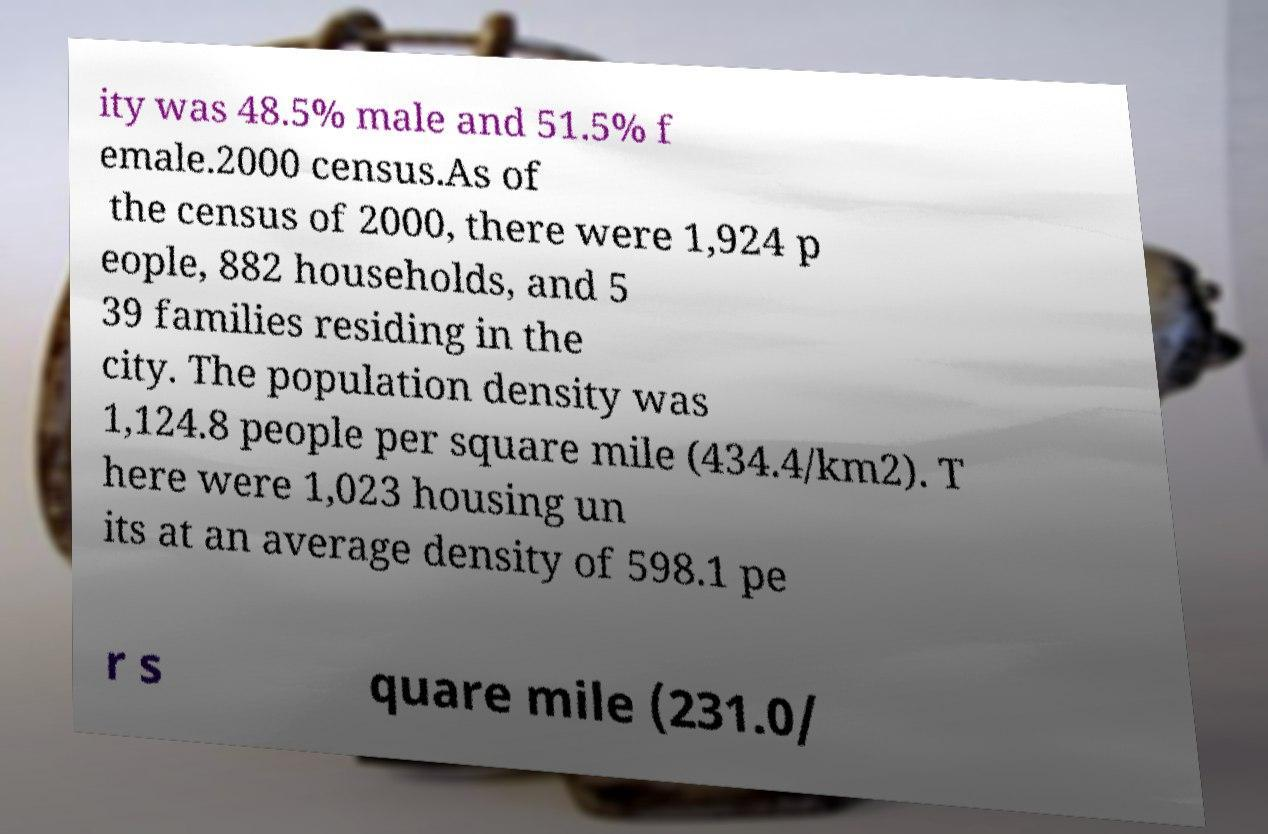Please read and relay the text visible in this image. What does it say? ity was 48.5% male and 51.5% f emale.2000 census.As of the census of 2000, there were 1,924 p eople, 882 households, and 5 39 families residing in the city. The population density was 1,124.8 people per square mile (434.4/km2). T here were 1,023 housing un its at an average density of 598.1 pe r s quare mile (231.0/ 